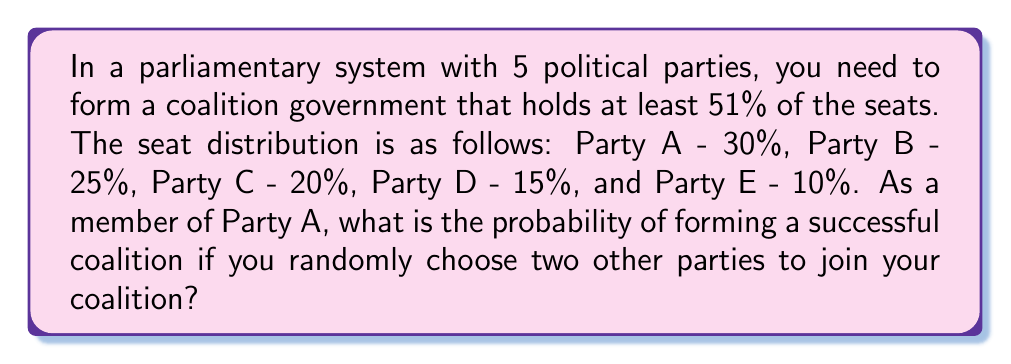Teach me how to tackle this problem. Let's approach this step-by-step:

1) First, we need to determine how many ways we can choose 2 parties out of the remaining 4 parties. This is a combination problem, denoted as $\binom{4}{2}$.

   $\binom{4}{2} = \frac{4!}{2!(4-2)!} = \frac{4 \cdot 3}{2 \cdot 1} = 6$

2) Now, we need to count how many of these combinations will result in a successful coalition (i.e., total seats ≥ 51%).

3) Let's list all possible combinations with Party A (30%):
   - A + B + C = 30% + 25% + 20% = 75%
   - A + B + D = 30% + 25% + 15% = 70%
   - A + B + E = 30% + 25% + 10% = 65%
   - A + C + D = 30% + 20% + 15% = 65%
   - A + C + E = 30% + 20% + 10% = 60%
   - A + D + E = 30% + 15% + 10% = 55%

4) All of these combinations exceed 51%, so all 6 possible coalitions are successful.

5) The probability is thus:

   $P(\text{successful coalition}) = \frac{\text{number of successful coalitions}}{\text{total number of possible coalitions}} = \frac{6}{6} = 1$
Answer: 1 